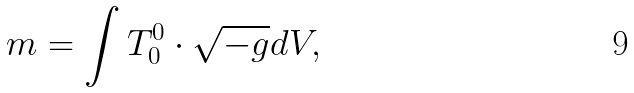Convert formula to latex. <formula><loc_0><loc_0><loc_500><loc_500>m = \int T _ { 0 } ^ { 0 } \cdot \sqrt { - g } d V ,</formula> 